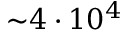Convert formula to latex. <formula><loc_0><loc_0><loc_500><loc_500>{ \sim } 4 \cdot 1 0 ^ { 4 }</formula> 